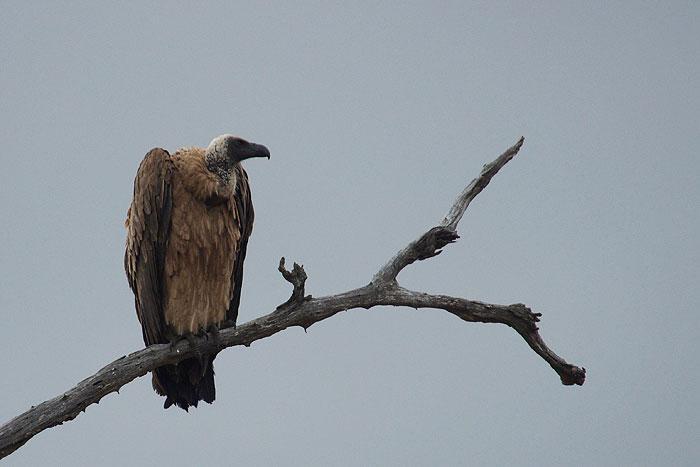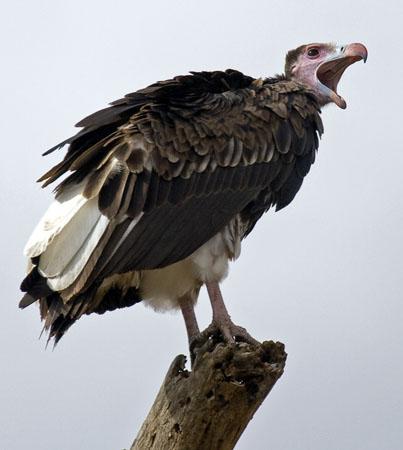The first image is the image on the left, the second image is the image on the right. Evaluate the accuracy of this statement regarding the images: "The bird in the image on the right is lying down.". Is it true? Answer yes or no. No. 